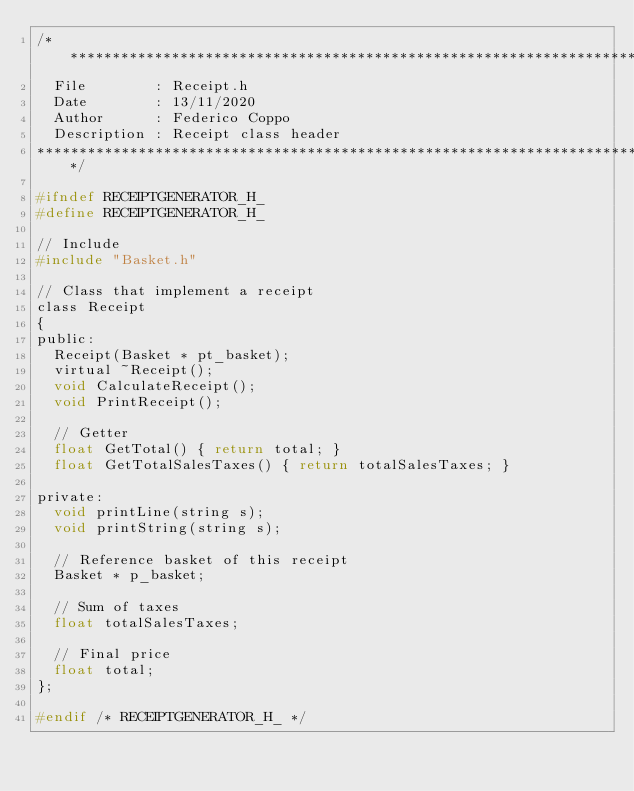<code> <loc_0><loc_0><loc_500><loc_500><_C_>/*******************************************************************************
	File        : Receipt.h
	Date        : 13/11/2020
	Author      : Federico Coppo
	Description : Receipt class header
*******************************************************************************/

#ifndef RECEIPTGENERATOR_H_
#define RECEIPTGENERATOR_H_

// Include
#include "Basket.h"

// Class that implement a receipt
class Receipt
{
public:
	Receipt(Basket * pt_basket);
	virtual ~Receipt();
	void CalculateReceipt();
	void PrintReceipt();

	// Getter
	float GetTotal() { return total; }
	float GetTotalSalesTaxes() { return totalSalesTaxes; }

private:
	void printLine(string s);
	void printString(string s);

	// Reference basket of this receipt
	Basket * p_basket;

	// Sum of taxes
	float totalSalesTaxes;

	// Final price
	float total;
};

#endif /* RECEIPTGENERATOR_H_ */
</code> 